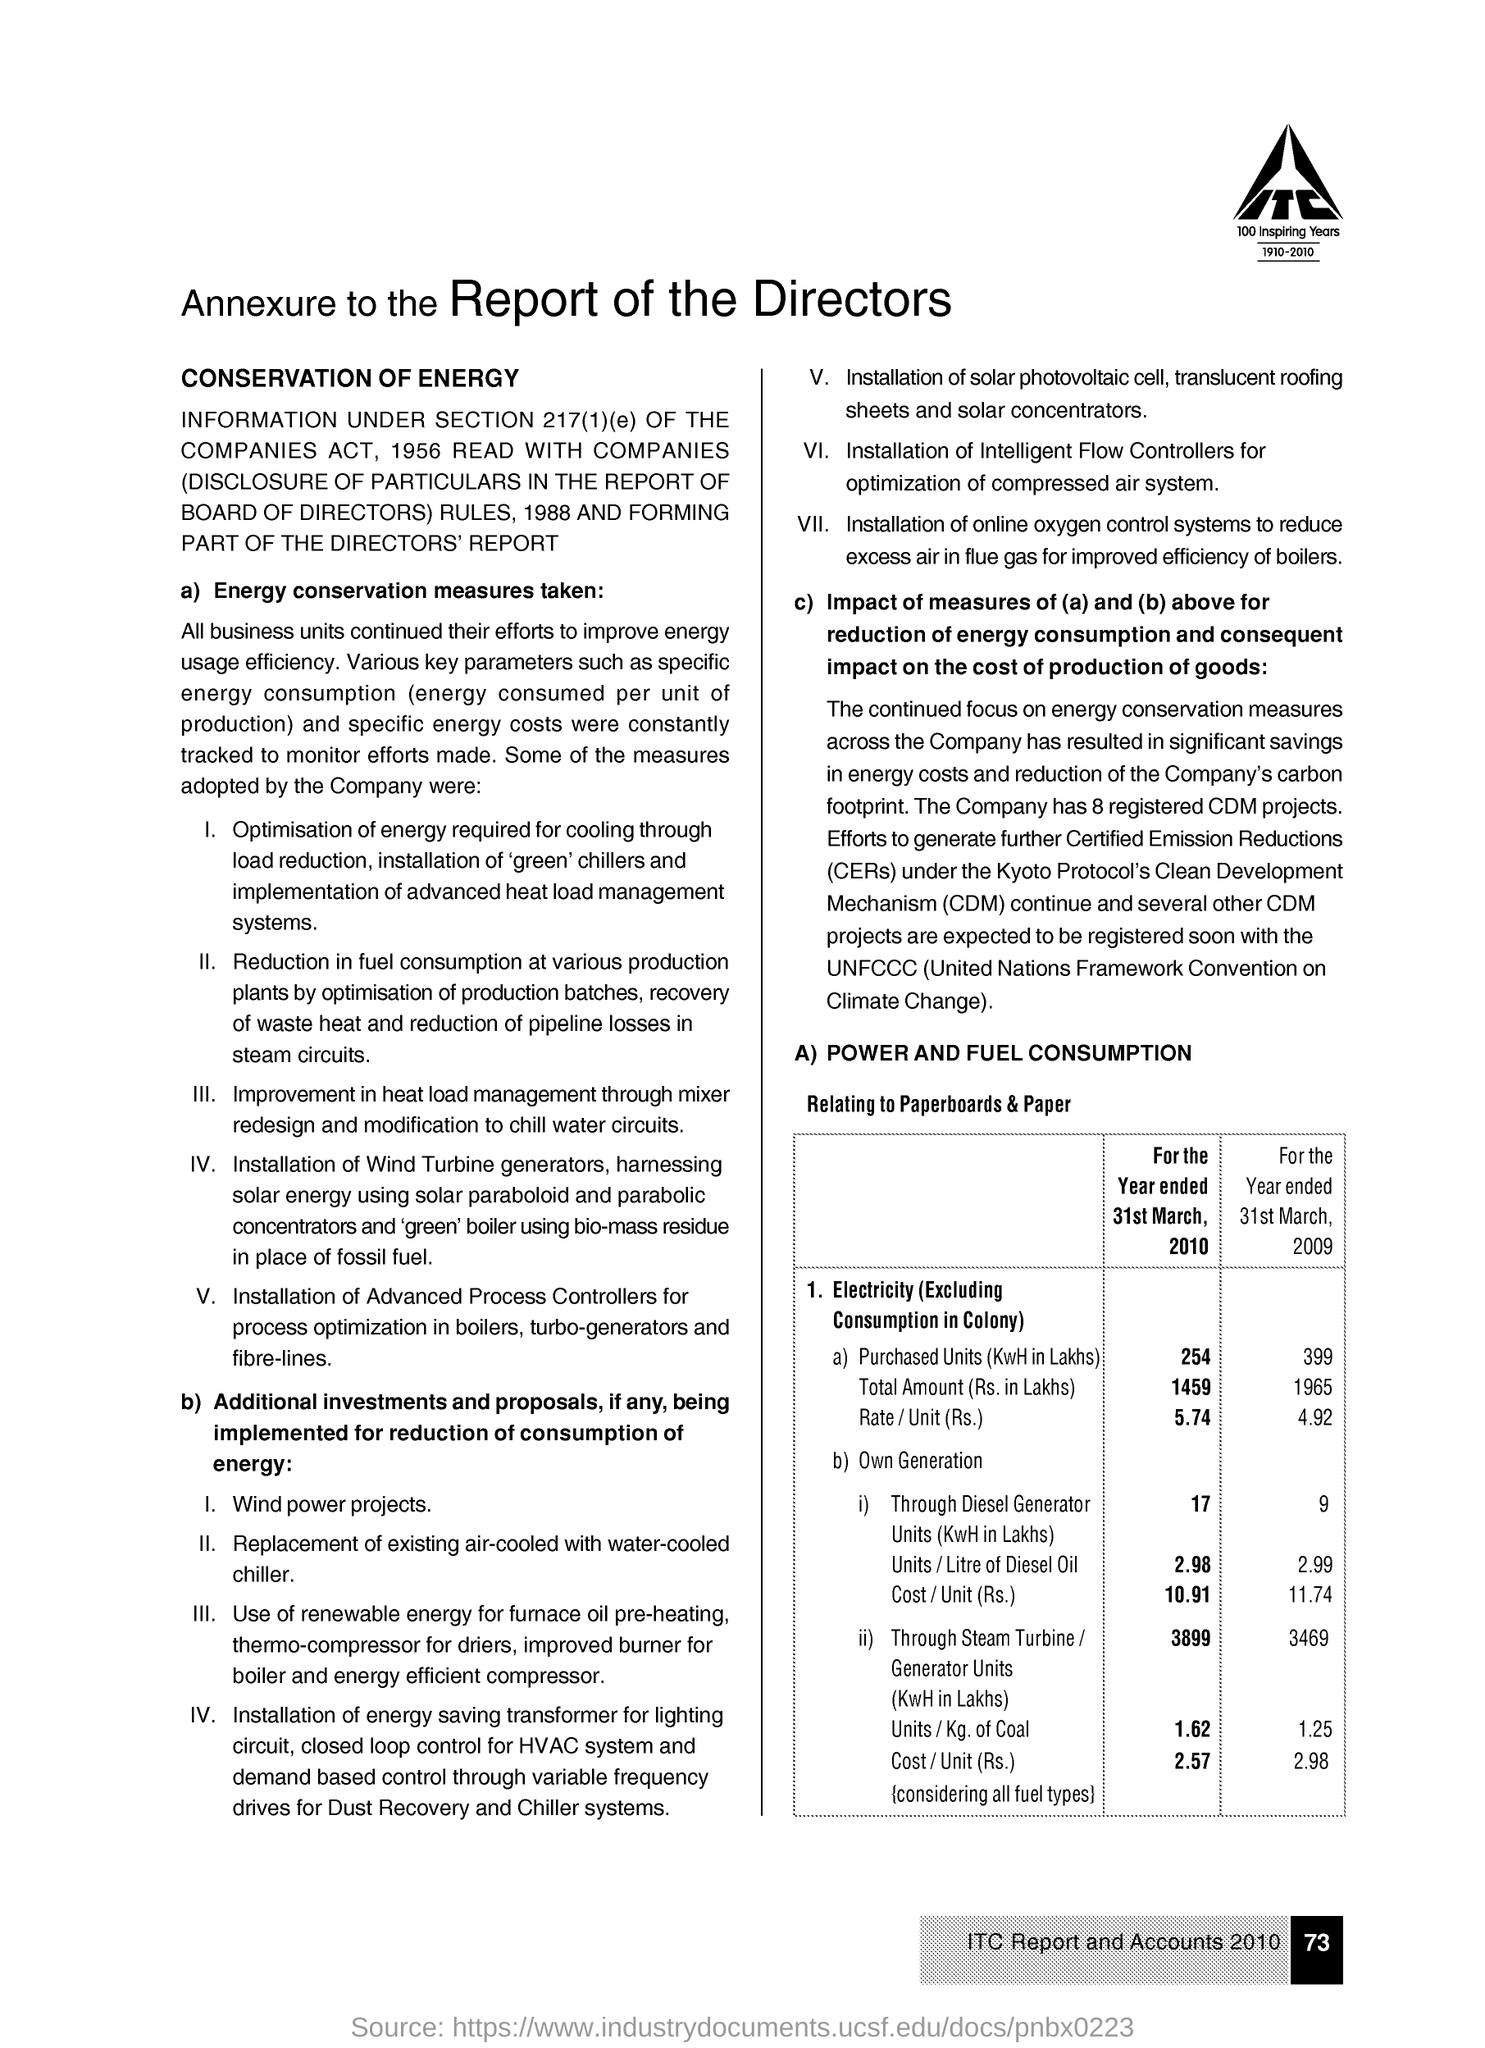What is the purchased Units (KwH in Lakhs) of Electricity (Excluding Consumption in colony) for the year ended 31st March, 2010?
Your answer should be very brief. 254. What is the purchased Units (KwH in Lakhs) of Electricity (Excluding Consumption in colony) for the year ended 31st March, 2009?
Keep it short and to the point. 399. What is the Rate/unit(Rs.) of Electricity(Excluding Consumption in Colony) for the year ended 31st March, 2010?
Keep it short and to the point. 5.74. What is the Rate/unit(Rs.) of Electricity(Excluding Consumption in Colony) for the year ended 31st March, 2009?
Your answer should be compact. 4.92. What is the full form of CERs ?
Offer a terse response. Certified Emission Reductions. What is the abbreviation for Clean Development Mechanism?
Keep it short and to the point. CDM. 